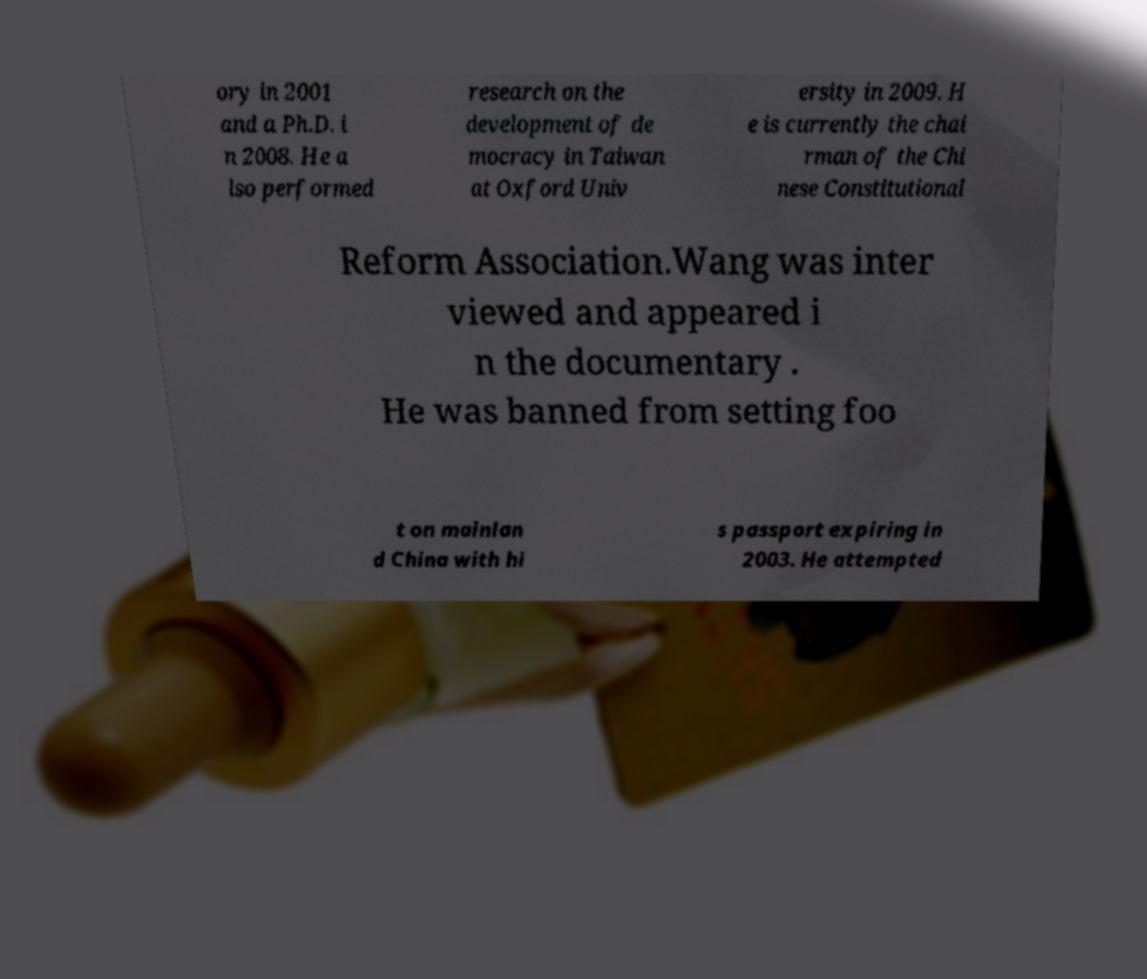There's text embedded in this image that I need extracted. Can you transcribe it verbatim? ory in 2001 and a Ph.D. i n 2008. He a lso performed research on the development of de mocracy in Taiwan at Oxford Univ ersity in 2009. H e is currently the chai rman of the Chi nese Constitutional Reform Association.Wang was inter viewed and appeared i n the documentary . He was banned from setting foo t on mainlan d China with hi s passport expiring in 2003. He attempted 